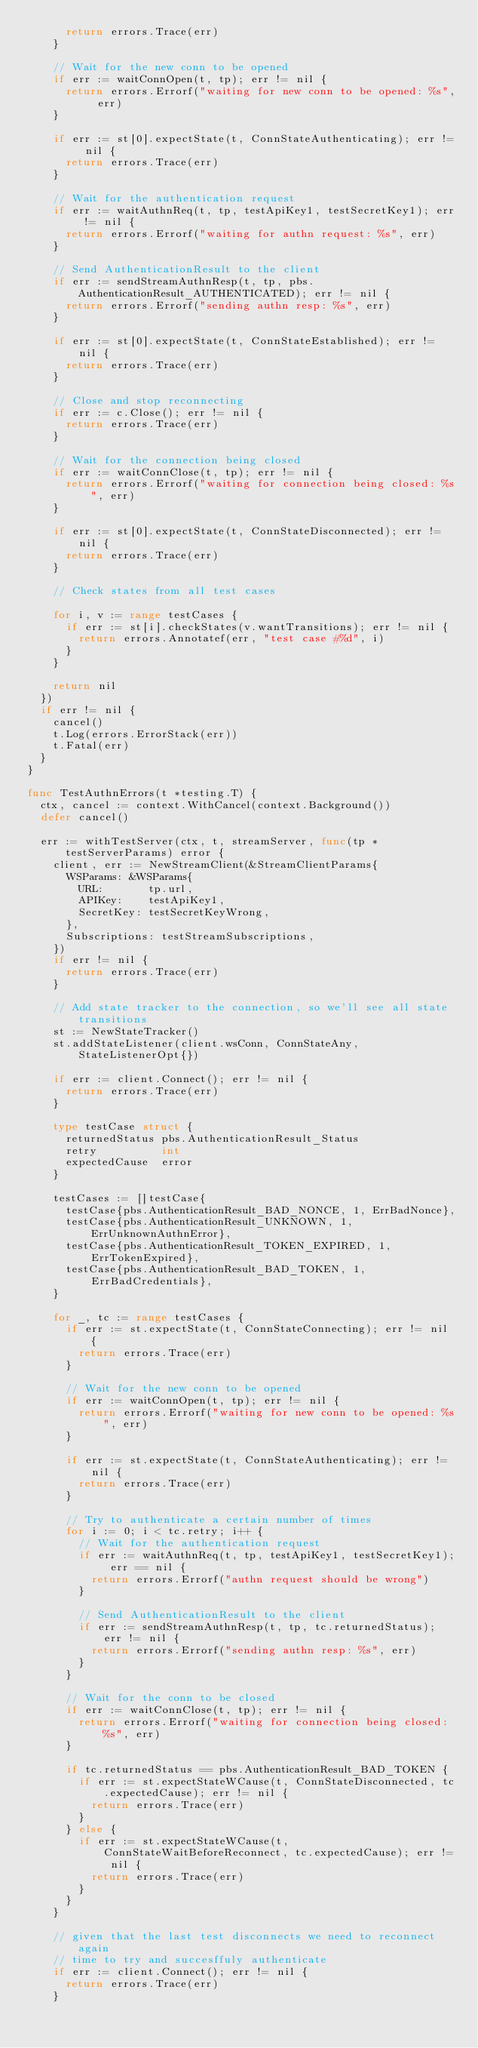<code> <loc_0><loc_0><loc_500><loc_500><_Go_>			return errors.Trace(err)
		}

		// Wait for the new conn to be opened
		if err := waitConnOpen(t, tp); err != nil {
			return errors.Errorf("waiting for new conn to be opened: %s", err)
		}

		if err := st[0].expectState(t, ConnStateAuthenticating); err != nil {
			return errors.Trace(err)
		}

		// Wait for the authentication request
		if err := waitAuthnReq(t, tp, testApiKey1, testSecretKey1); err != nil {
			return errors.Errorf("waiting for authn request: %s", err)
		}

		// Send AuthenticationResult to the client
		if err := sendStreamAuthnResp(t, tp, pbs.AuthenticationResult_AUTHENTICATED); err != nil {
			return errors.Errorf("sending authn resp: %s", err)
		}

		if err := st[0].expectState(t, ConnStateEstablished); err != nil {
			return errors.Trace(err)
		}

		// Close and stop reconnecting
		if err := c.Close(); err != nil {
			return errors.Trace(err)
		}

		// Wait for the connection being closed
		if err := waitConnClose(t, tp); err != nil {
			return errors.Errorf("waiting for connection being closed: %s", err)
		}

		if err := st[0].expectState(t, ConnStateDisconnected); err != nil {
			return errors.Trace(err)
		}

		// Check states from all test cases

		for i, v := range testCases {
			if err := st[i].checkStates(v.wantTransitions); err != nil {
				return errors.Annotatef(err, "test case #%d", i)
			}
		}

		return nil
	})
	if err != nil {
		cancel()
		t.Log(errors.ErrorStack(err))
		t.Fatal(err)
	}
}

func TestAuthnErrors(t *testing.T) {
	ctx, cancel := context.WithCancel(context.Background())
	defer cancel()

	err := withTestServer(ctx, t, streamServer, func(tp *testServerParams) error {
		client, err := NewStreamClient(&StreamClientParams{
			WSParams: &WSParams{
				URL:       tp.url,
				APIKey:    testApiKey1,
				SecretKey: testSecretKeyWrong,
			},
			Subscriptions: testStreamSubscriptions,
		})
		if err != nil {
			return errors.Trace(err)
		}

		// Add state tracker to the connection, so we'll see all state transitions
		st := NewStateTracker()
		st.addStateListener(client.wsConn, ConnStateAny, StateListenerOpt{})

		if err := client.Connect(); err != nil {
			return errors.Trace(err)
		}

		type testCase struct {
			returnedStatus pbs.AuthenticationResult_Status
			retry          int
			expectedCause  error
		}

		testCases := []testCase{
			testCase{pbs.AuthenticationResult_BAD_NONCE, 1, ErrBadNonce},
			testCase{pbs.AuthenticationResult_UNKNOWN, 1, ErrUnknownAuthnError},
			testCase{pbs.AuthenticationResult_TOKEN_EXPIRED, 1, ErrTokenExpired},
			testCase{pbs.AuthenticationResult_BAD_TOKEN, 1, ErrBadCredentials},
		}

		for _, tc := range testCases {
			if err := st.expectState(t, ConnStateConnecting); err != nil {
				return errors.Trace(err)
			}

			// Wait for the new conn to be opened
			if err := waitConnOpen(t, tp); err != nil {
				return errors.Errorf("waiting for new conn to be opened: %s", err)
			}

			if err := st.expectState(t, ConnStateAuthenticating); err != nil {
				return errors.Trace(err)
			}

			// Try to authenticate a certain number of times
			for i := 0; i < tc.retry; i++ {
				// Wait for the authentication request
				if err := waitAuthnReq(t, tp, testApiKey1, testSecretKey1); err == nil {
					return errors.Errorf("authn request should be wrong")
				}

				// Send AuthenticationResult to the client
				if err := sendStreamAuthnResp(t, tp, tc.returnedStatus); err != nil {
					return errors.Errorf("sending authn resp: %s", err)
				}
			}

			// Wait for the conn to be closed
			if err := waitConnClose(t, tp); err != nil {
				return errors.Errorf("waiting for connection being closed: %s", err)
			}

			if tc.returnedStatus == pbs.AuthenticationResult_BAD_TOKEN {
				if err := st.expectStateWCause(t, ConnStateDisconnected, tc.expectedCause); err != nil {
					return errors.Trace(err)
				}
			} else {
				if err := st.expectStateWCause(t, ConnStateWaitBeforeReconnect, tc.expectedCause); err != nil {
					return errors.Trace(err)
				}
			}
		}

		// given that the last test disconnects we need to reconnect again
		// time to try and succesffuly authenticate
		if err := client.Connect(); err != nil {
			return errors.Trace(err)
		}
</code> 